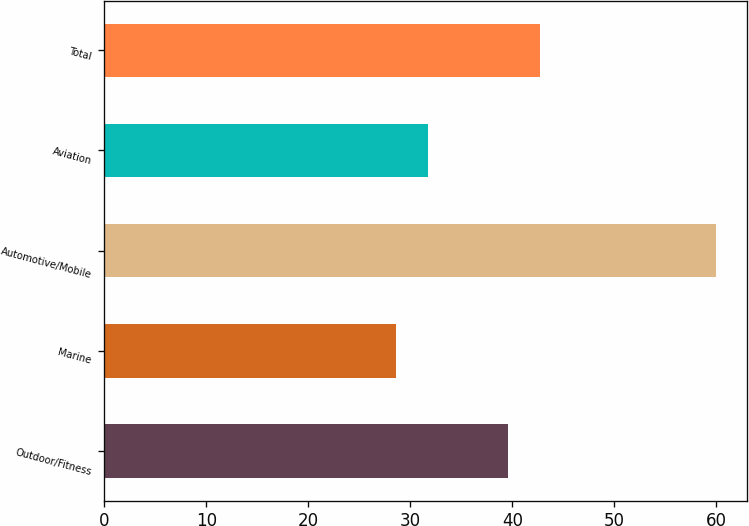Convert chart to OTSL. <chart><loc_0><loc_0><loc_500><loc_500><bar_chart><fcel>Outdoor/Fitness<fcel>Marine<fcel>Automotive/Mobile<fcel>Aviation<fcel>Total<nl><fcel>39.6<fcel>28.6<fcel>60<fcel>31.74<fcel>42.74<nl></chart> 